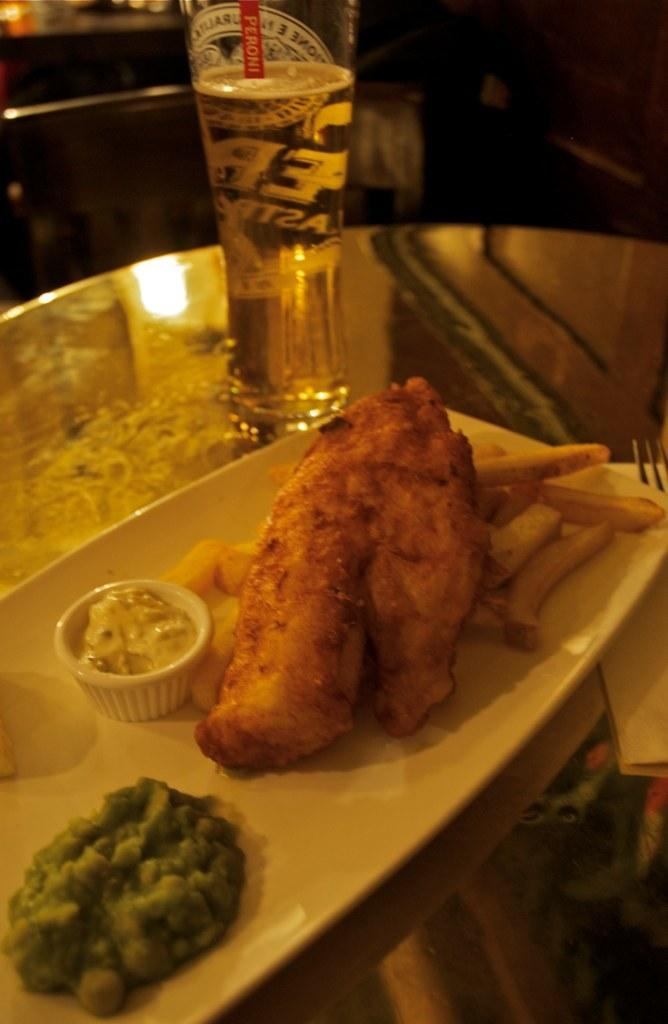<image>
Write a terse but informative summary of the picture. a fried fish and chips dinner with a glass of peroni 